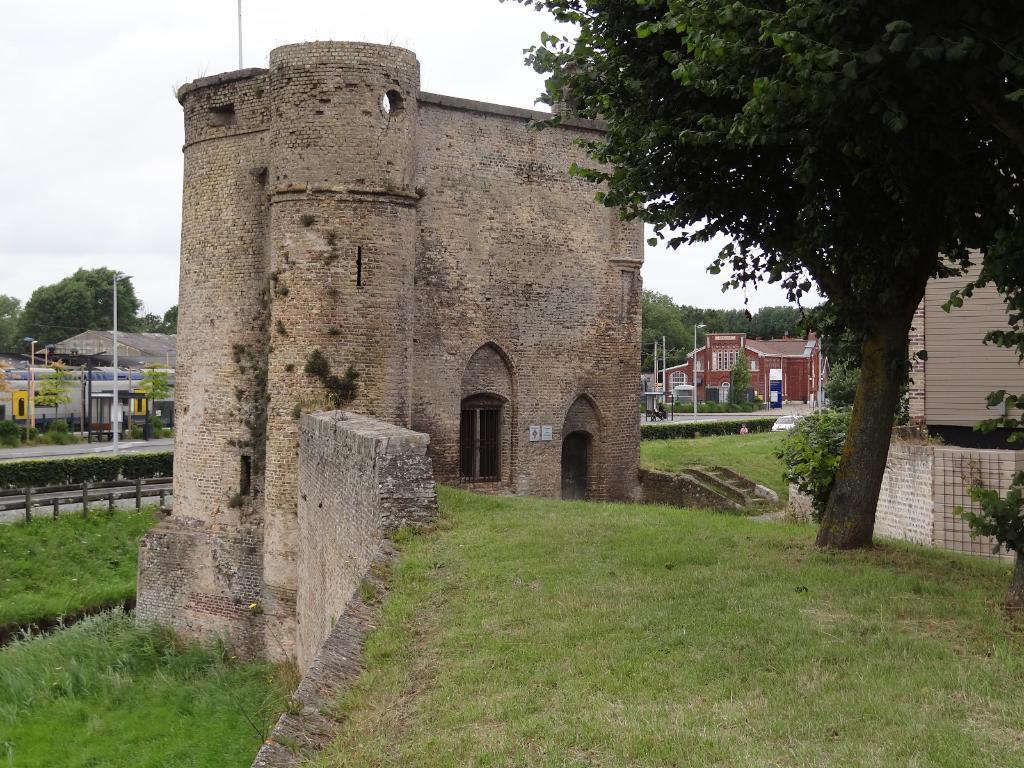In one or two sentences, can you explain what this image depicts? In this image I can see a fort, buildings, streetlights, fence and the grass. In the background I can see trees and the sky. 